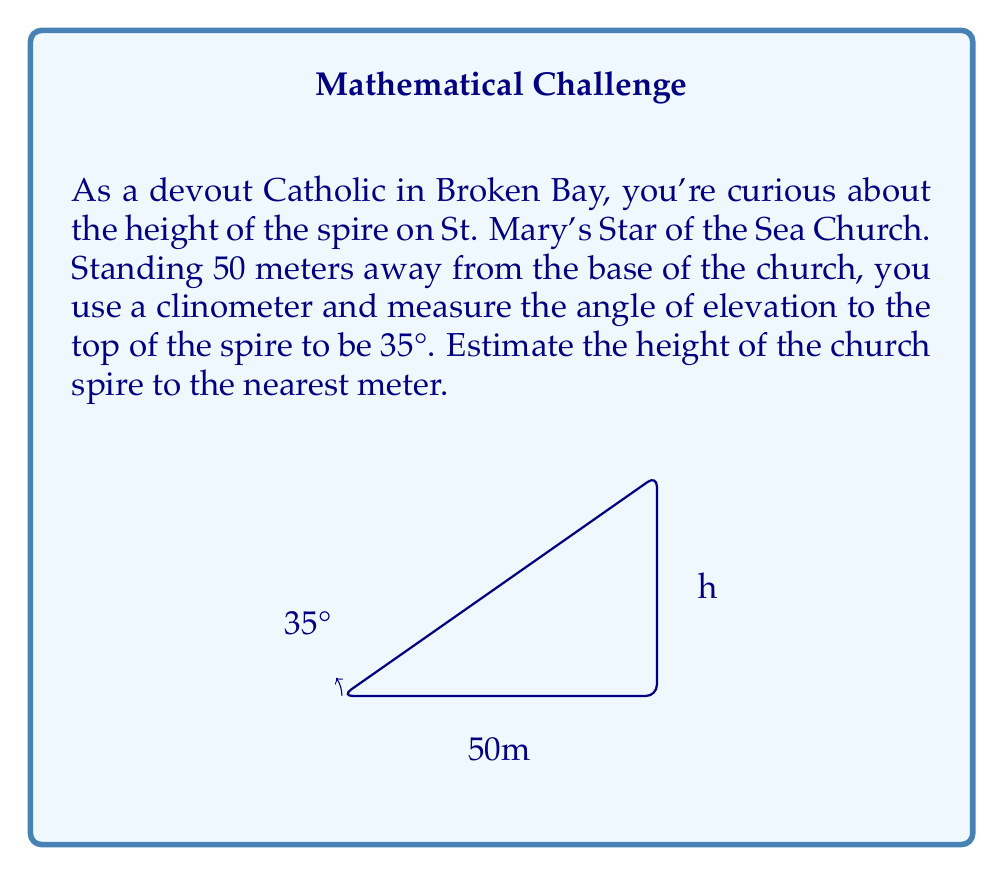Can you answer this question? To solve this problem, we'll use trigonometry, specifically the tangent function.

1) In a right-angled triangle, tangent of an angle is the ratio of the opposite side to the adjacent side.

   $$ \tan(\theta) = \frac{\text{opposite}}{\text{adjacent}} $$

2) In our case:
   - The angle of elevation ($\theta$) is 35°
   - The adjacent side (distance from you to the base of the church) is 50 meters
   - The opposite side is the height of the spire (h), which we need to find

3) We can set up the equation:

   $$ \tan(35°) = \frac{h}{50} $$

4) To solve for h, multiply both sides by 50:

   $$ h = 50 \tan(35°) $$

5) Using a calculator (or trigonometric tables):

   $$ h = 50 \times 0.7002 = 35.01 \text{ meters} $$

6) Rounding to the nearest meter:

   $$ h \approx 35 \text{ meters} $$
Answer: The estimated height of the church spire is 35 meters. 